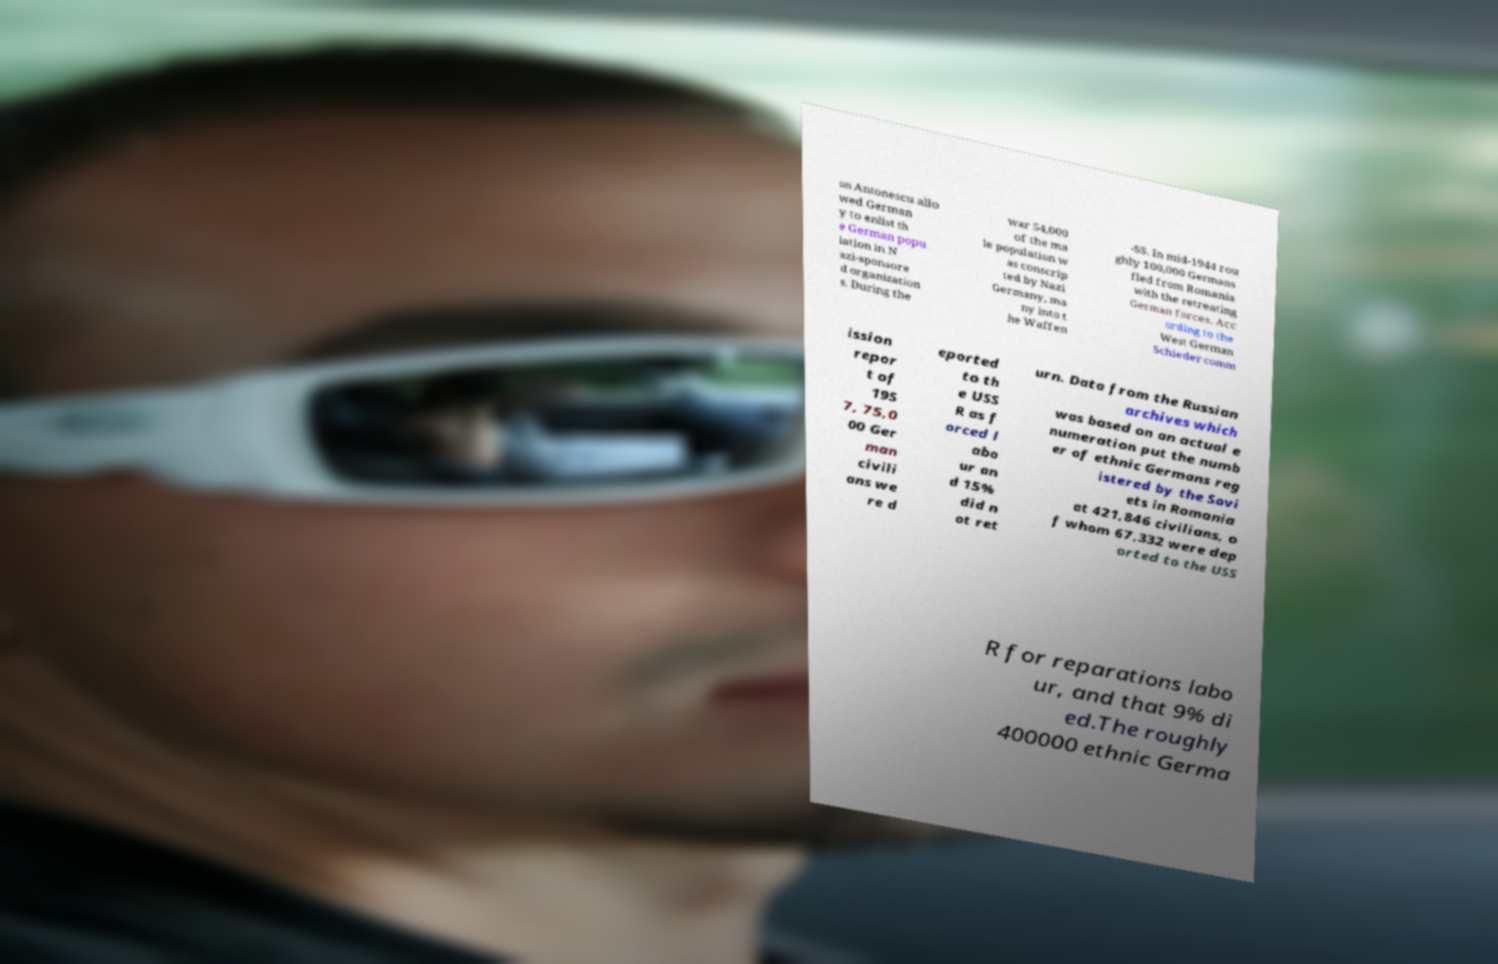For documentation purposes, I need the text within this image transcribed. Could you provide that? on Antonescu allo wed German y to enlist th e German popu lation in N azi-sponsore d organization s. During the war 54,000 of the ma le population w as conscrip ted by Nazi Germany, ma ny into t he Waffen -SS. In mid-1944 rou ghly 100,000 Germans fled from Romania with the retreating German forces. Acc ording to the West German Schieder comm ission repor t of 195 7, 75,0 00 Ger man civili ans we re d eported to th e USS R as f orced l abo ur an d 15% did n ot ret urn. Data from the Russian archives which was based on an actual e numeration put the numb er of ethnic Germans reg istered by the Sovi ets in Romania at 421,846 civilians, o f whom 67,332 were dep orted to the USS R for reparations labo ur, and that 9% di ed.The roughly 400000 ethnic Germa 